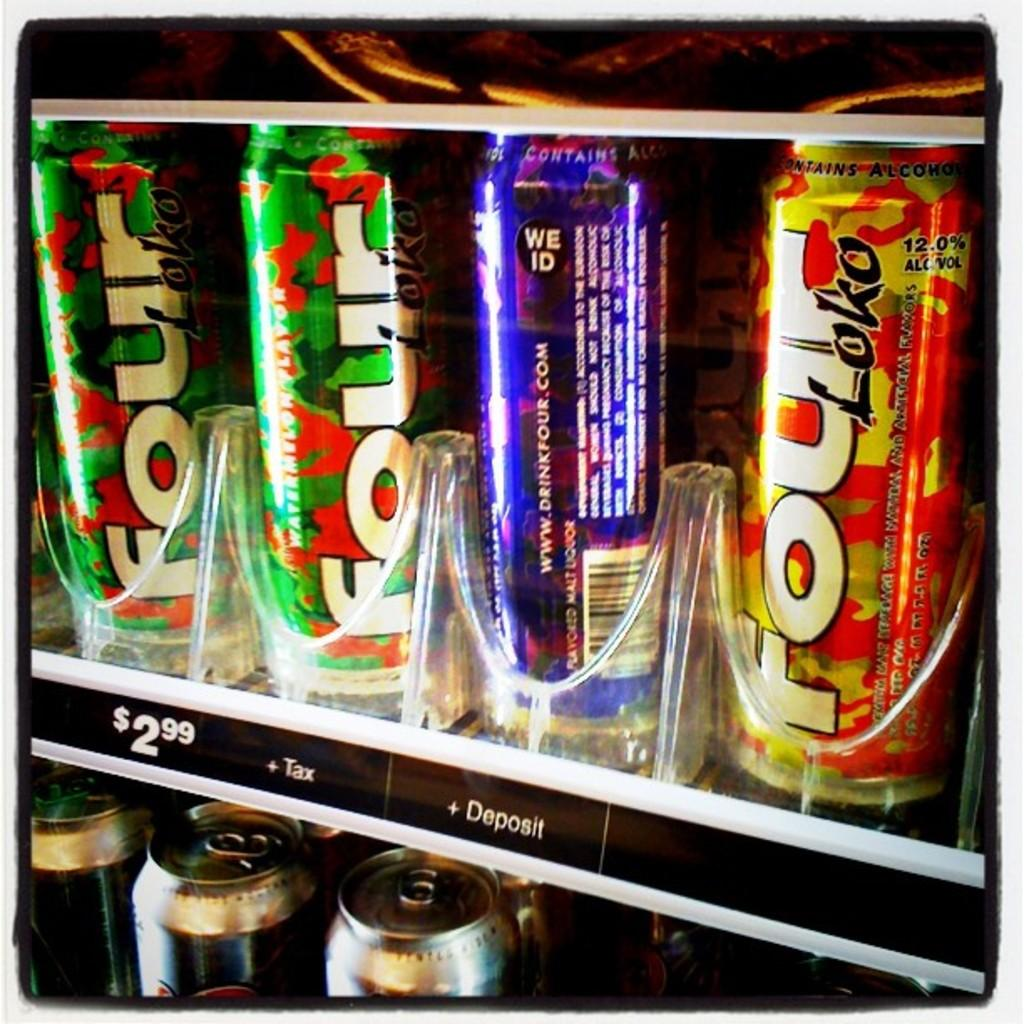<image>
Give a short and clear explanation of the subsequent image. Several Four Loko cans are in a vending machine. 